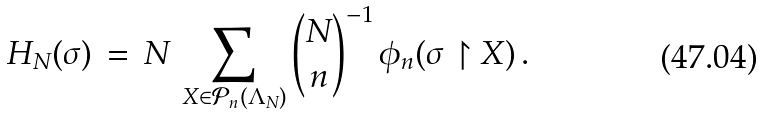Convert formula to latex. <formula><loc_0><loc_0><loc_500><loc_500>H _ { N } ( \sigma ) \, = \, N \, \sum _ { X \in \mathcal { P } _ { n } ( \Lambda _ { N } ) } \binom { N } { n } ^ { - 1 } \, \phi _ { n } ( \sigma \restriction X ) \, .</formula> 